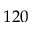<formula> <loc_0><loc_0><loc_500><loc_500>1 2 0</formula> 